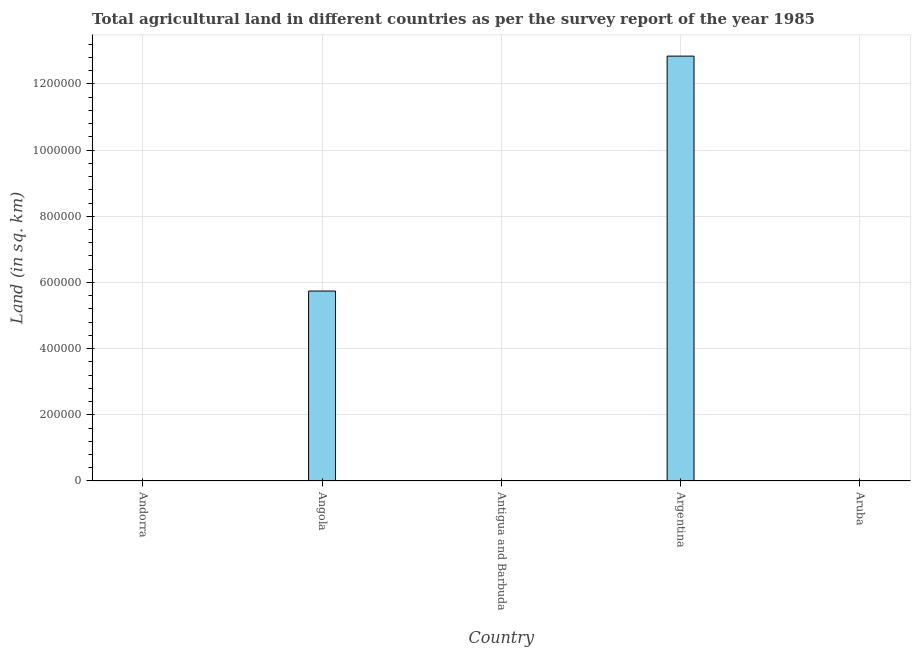Does the graph contain any zero values?
Give a very brief answer. No. Does the graph contain grids?
Keep it short and to the point. Yes. What is the title of the graph?
Ensure brevity in your answer.  Total agricultural land in different countries as per the survey report of the year 1985. What is the label or title of the Y-axis?
Provide a succinct answer. Land (in sq. km). Across all countries, what is the maximum agricultural land?
Offer a very short reply. 1.28e+06. Across all countries, what is the minimum agricultural land?
Keep it short and to the point. 20. In which country was the agricultural land maximum?
Make the answer very short. Argentina. In which country was the agricultural land minimum?
Your answer should be very brief. Aruba. What is the sum of the agricultural land?
Make the answer very short. 1.86e+06. What is the difference between the agricultural land in Angola and Argentina?
Provide a short and direct response. -7.10e+05. What is the average agricultural land per country?
Your response must be concise. 3.72e+05. In how many countries, is the agricultural land greater than 240000 sq. km?
Your response must be concise. 2. What is the ratio of the agricultural land in Antigua and Barbuda to that in Aruba?
Keep it short and to the point. 4.5. What is the difference between the highest and the second highest agricultural land?
Your answer should be very brief. 7.10e+05. What is the difference between the highest and the lowest agricultural land?
Provide a short and direct response. 1.28e+06. Are all the bars in the graph horizontal?
Your answer should be very brief. No. What is the difference between two consecutive major ticks on the Y-axis?
Give a very brief answer. 2.00e+05. Are the values on the major ticks of Y-axis written in scientific E-notation?
Your response must be concise. No. What is the Land (in sq. km) in Andorra?
Keep it short and to the point. 200. What is the Land (in sq. km) of Angola?
Your answer should be compact. 5.74e+05. What is the Land (in sq. km) in Antigua and Barbuda?
Keep it short and to the point. 90. What is the Land (in sq. km) of Argentina?
Give a very brief answer. 1.28e+06. What is the Land (in sq. km) in Aruba?
Keep it short and to the point. 20. What is the difference between the Land (in sq. km) in Andorra and Angola?
Give a very brief answer. -5.74e+05. What is the difference between the Land (in sq. km) in Andorra and Antigua and Barbuda?
Your response must be concise. 110. What is the difference between the Land (in sq. km) in Andorra and Argentina?
Provide a short and direct response. -1.28e+06. What is the difference between the Land (in sq. km) in Andorra and Aruba?
Offer a very short reply. 180. What is the difference between the Land (in sq. km) in Angola and Antigua and Barbuda?
Provide a succinct answer. 5.74e+05. What is the difference between the Land (in sq. km) in Angola and Argentina?
Offer a terse response. -7.10e+05. What is the difference between the Land (in sq. km) in Angola and Aruba?
Offer a very short reply. 5.74e+05. What is the difference between the Land (in sq. km) in Antigua and Barbuda and Argentina?
Your response must be concise. -1.28e+06. What is the difference between the Land (in sq. km) in Antigua and Barbuda and Aruba?
Offer a very short reply. 70. What is the difference between the Land (in sq. km) in Argentina and Aruba?
Offer a very short reply. 1.28e+06. What is the ratio of the Land (in sq. km) in Andorra to that in Angola?
Provide a short and direct response. 0. What is the ratio of the Land (in sq. km) in Andorra to that in Antigua and Barbuda?
Your answer should be compact. 2.22. What is the ratio of the Land (in sq. km) in Andorra to that in Argentina?
Make the answer very short. 0. What is the ratio of the Land (in sq. km) in Angola to that in Antigua and Barbuda?
Your answer should be compact. 6377.78. What is the ratio of the Land (in sq. km) in Angola to that in Argentina?
Provide a succinct answer. 0.45. What is the ratio of the Land (in sq. km) in Angola to that in Aruba?
Provide a short and direct response. 2.87e+04. What is the ratio of the Land (in sq. km) in Antigua and Barbuda to that in Argentina?
Make the answer very short. 0. What is the ratio of the Land (in sq. km) in Antigua and Barbuda to that in Aruba?
Make the answer very short. 4.5. What is the ratio of the Land (in sq. km) in Argentina to that in Aruba?
Ensure brevity in your answer.  6.42e+04. 